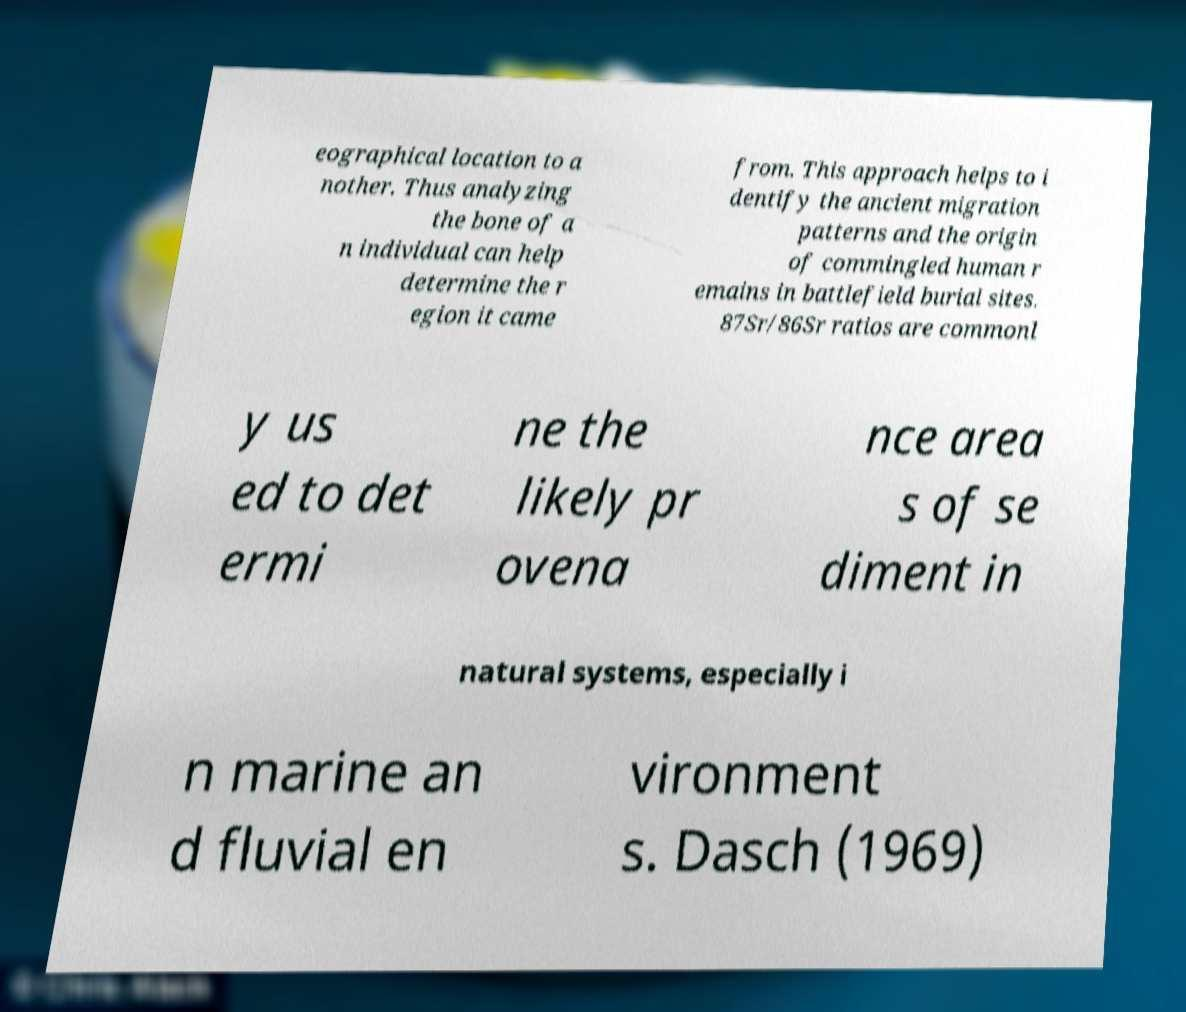What messages or text are displayed in this image? I need them in a readable, typed format. eographical location to a nother. Thus analyzing the bone of a n individual can help determine the r egion it came from. This approach helps to i dentify the ancient migration patterns and the origin of commingled human r emains in battlefield burial sites. 87Sr/86Sr ratios are commonl y us ed to det ermi ne the likely pr ovena nce area s of se diment in natural systems, especially i n marine an d fluvial en vironment s. Dasch (1969) 